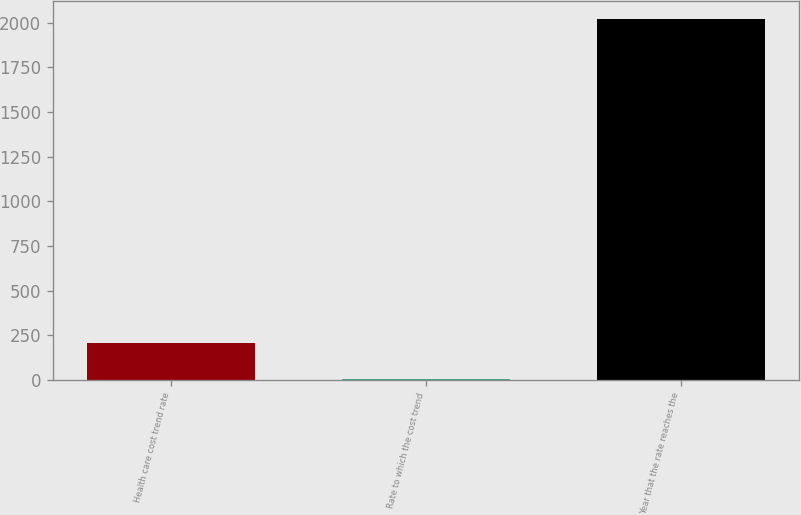Convert chart to OTSL. <chart><loc_0><loc_0><loc_500><loc_500><bar_chart><fcel>Health care cost trend rate<fcel>Rate to which the cost trend<fcel>Year that the rate reaches the<nl><fcel>206.05<fcel>4.5<fcel>2020<nl></chart> 